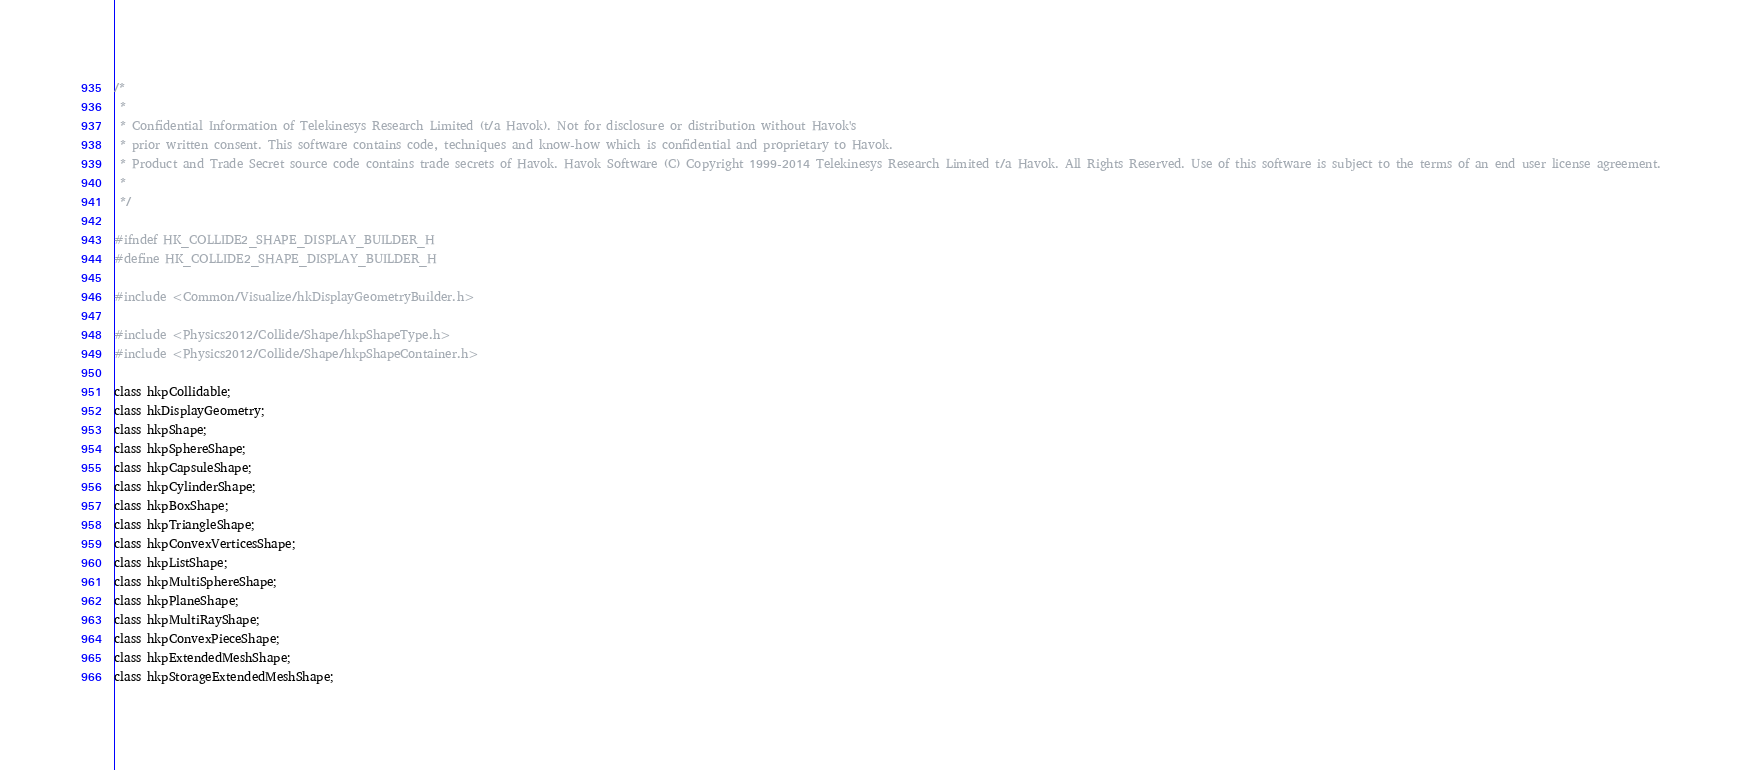<code> <loc_0><loc_0><loc_500><loc_500><_C_>/*
 *
 * Confidential Information of Telekinesys Research Limited (t/a Havok). Not for disclosure or distribution without Havok's
 * prior written consent. This software contains code, techniques and know-how which is confidential and proprietary to Havok.
 * Product and Trade Secret source code contains trade secrets of Havok. Havok Software (C) Copyright 1999-2014 Telekinesys Research Limited t/a Havok. All Rights Reserved. Use of this software is subject to the terms of an end user license agreement.
 *
 */

#ifndef HK_COLLIDE2_SHAPE_DISPLAY_BUILDER_H
#define HK_COLLIDE2_SHAPE_DISPLAY_BUILDER_H

#include <Common/Visualize/hkDisplayGeometryBuilder.h>

#include <Physics2012/Collide/Shape/hkpShapeType.h>
#include <Physics2012/Collide/Shape/hkpShapeContainer.h>

class hkpCollidable;
class hkDisplayGeometry;
class hkpShape;
class hkpSphereShape;
class hkpCapsuleShape;
class hkpCylinderShape;
class hkpBoxShape;
class hkpTriangleShape;
class hkpConvexVerticesShape;
class hkpListShape;
class hkpMultiSphereShape;
class hkpPlaneShape;
class hkpMultiRayShape;
class hkpConvexPieceShape;
class hkpExtendedMeshShape;
class hkpStorageExtendedMeshShape;</code> 